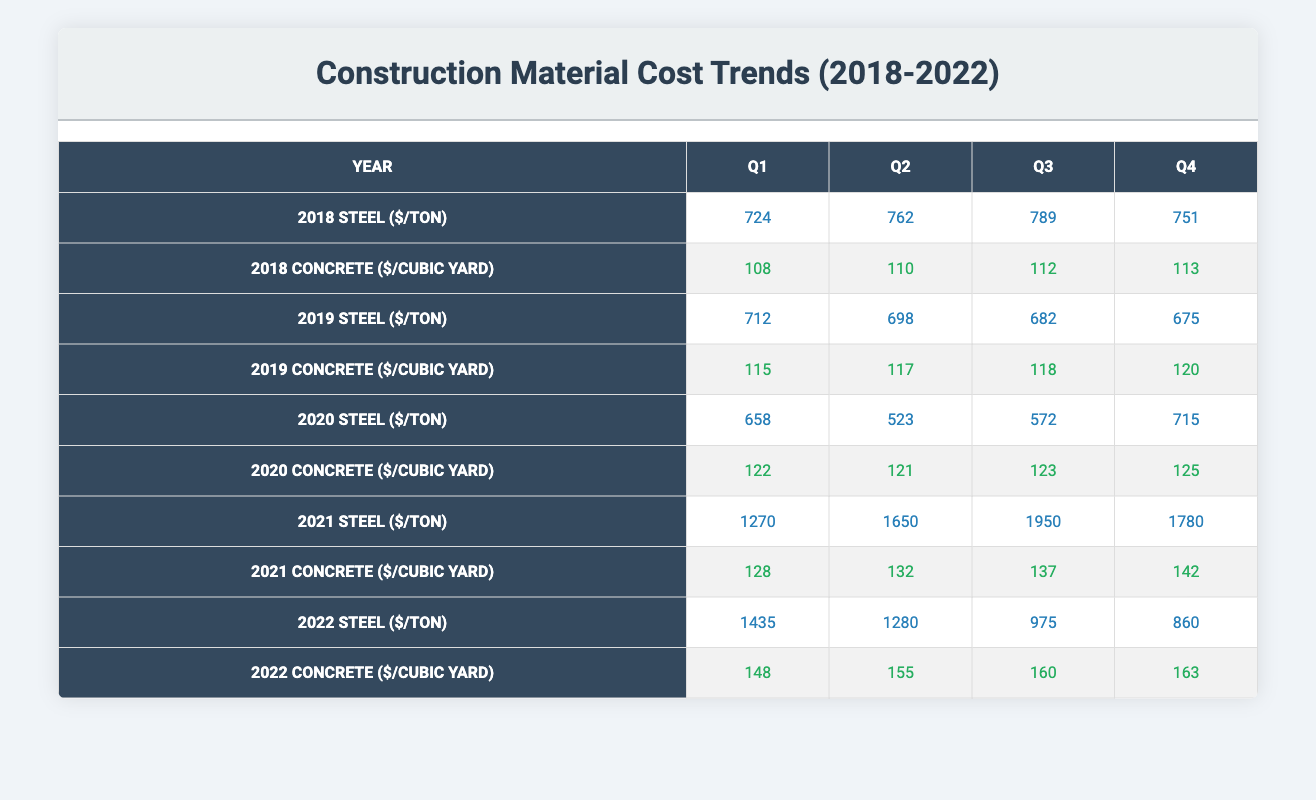What was the highest price of steel per ton throughout 2018? In 2018, the quarter with the highest price for steel can be found in the table. Q3 of 2018 shows a price of 789 per ton, which is the highest across all quarters in that year.
Answer: 789 What was the price of concrete per cubic yard in Q4 of 2021? Looking at the table, for 2021 in Q4, the price of concrete per cubic yard is stated as 142.
Answer: 142 Which quarter in 2022 had the lowest price of steel per ton? In 2022, the prices for steel per ton are listed: Q1 (1435), Q2 (1280), Q3 (975), and Q4 (860). Q3 has the lowest price at 975 per ton.
Answer: 975 What was the average price of concrete per cubic yard across all quarters in 2020? To calculate the average price for concrete in 2020, we take the values from each quarter: Q1 (122), Q2 (121), Q3 (123), Q4 (125). We total these prices: 122 + 121 + 123 + 125 = 491. Then, divide by 4 to find the average: 491 / 4 = 122.75.
Answer: 122.75 Is Q2 of 2019 the only quarter where the price of concrete per cubic yard did not exceed 120? Reviewing Q2 of 2019, the price is 117, which is less than 120. However, Q4 of 2019 has a price of 120, meaning it does not exceed 120 but is equal to that value. Therefore, Q2 is not the only instance where this occurs because Q4 also matches this criterion.
Answer: No What was the rate of increase in the price of steel per ton from Q3 2020 to Q4 2020? From Q3 2020, the price of steel was 572 per ton, and by Q4 2020, it increased to 715 per ton. The difference in price is 715 - 572 = 143. Therefore, the rate of increase is 143 per ton from Q3 to Q4 2020.
Answer: 143 In which year did steel prices surpass $1000 per ton for the first time? Examining the table, steel prices exceed $1000 per ton starting in Q1 of 2021 with a price of 1270. Therefore, 2021 is the first year this happens.
Answer: 2021 What were the quarterly concrete prices for Q3 of 2021 and 2022, and how do they compare? For Q3, 2021, the price of concrete is 137, while for Q3 of 2022, the price is 160. Thus, 160 (2022) is higher than 137 (2021) with a difference of 23.
Answer: 23 higher 